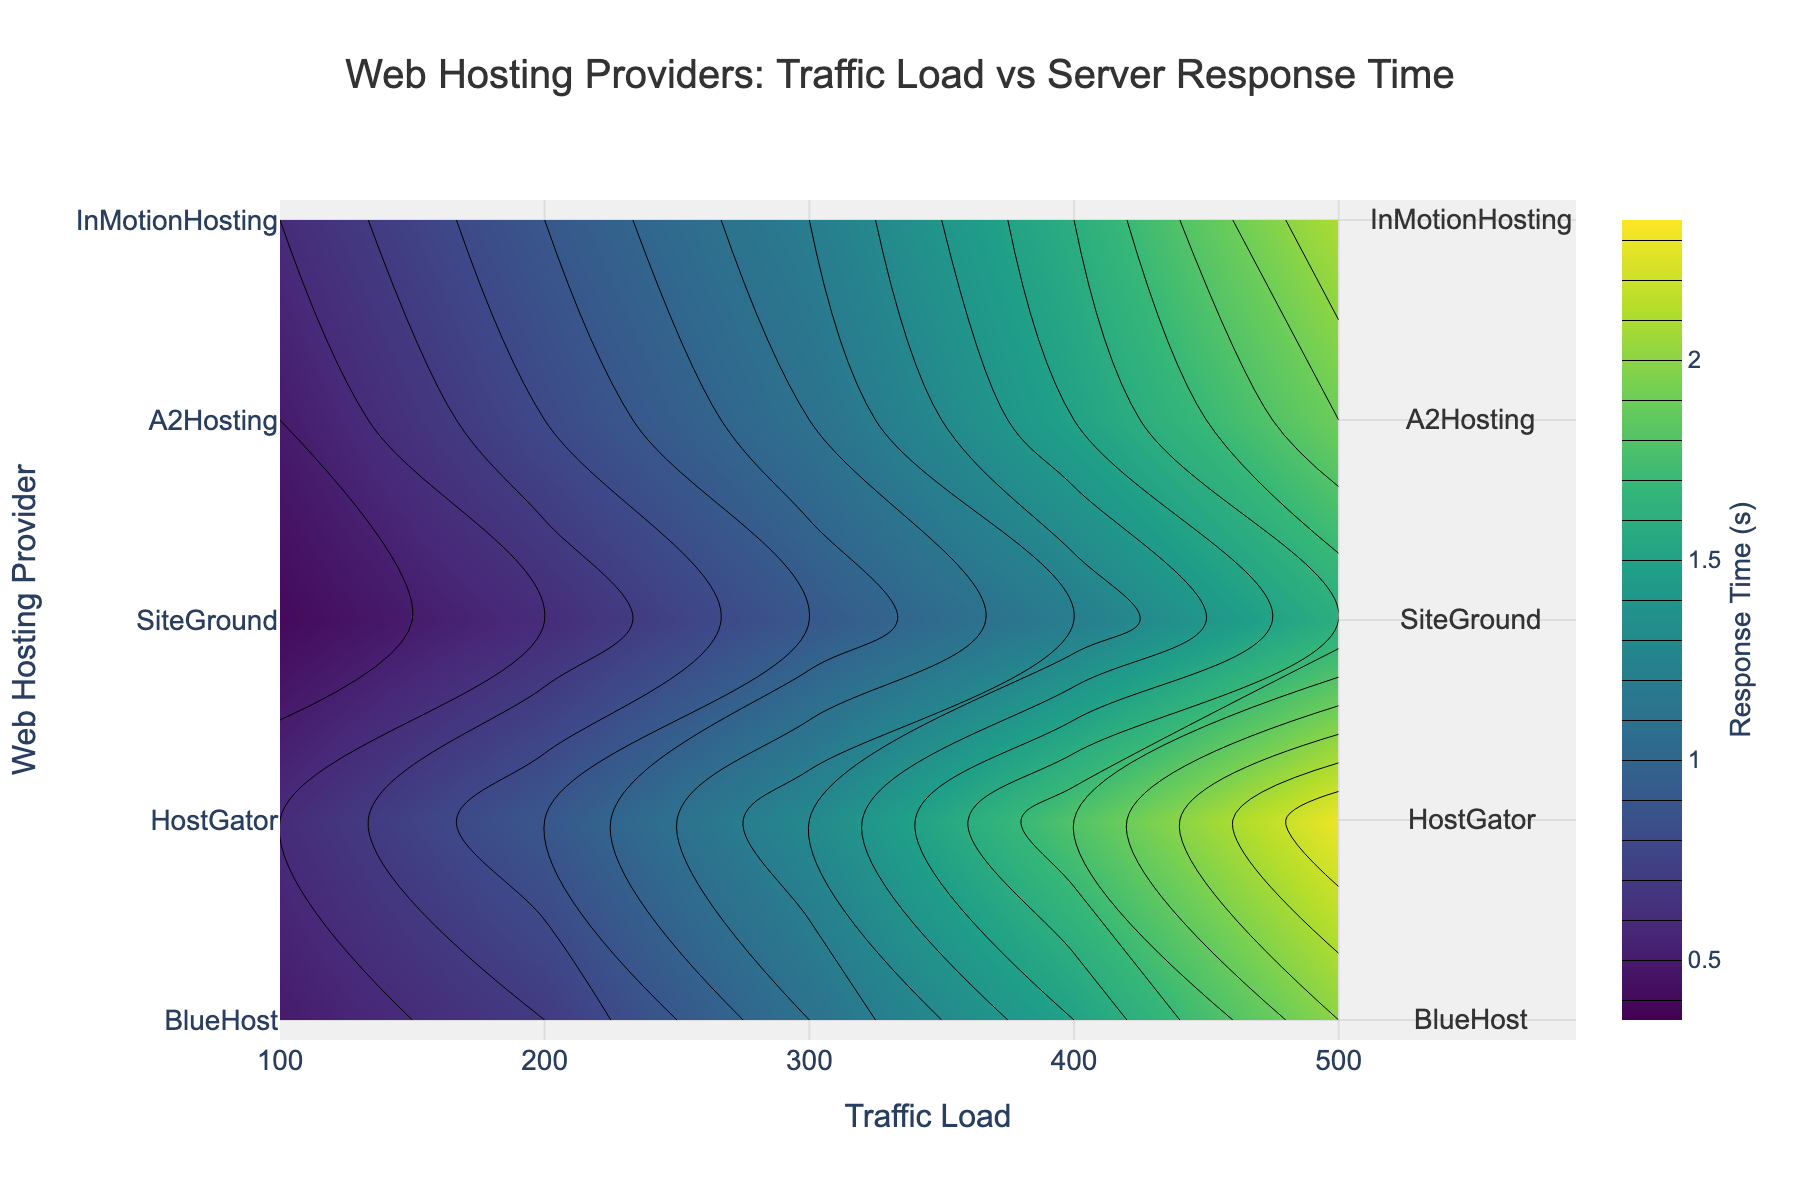What is the title of the plot? The title of the plot is usually placed at the top center of the figure, in this case, it reads 'Web Hosting Providers: Traffic Load vs Server Response Time'.
Answer: Web Hosting Providers: Traffic Load vs Server Response Time What information is displayed on the x-axis? The x-axis represents the 'Traffic Load', as indicated by the label at the bottom of the axis in the figure.
Answer: Traffic Load How many web hosting providers are displayed in the figure? The y-axis lists all web hosting providers, and by counting the distinct labels, there are 5 web hosting providers.
Answer: 5 Which web hosting provider has the lowest server response time at the highest traffic load? By checking the contour lines at the highest traffic load (500), the provider with the lowest response time is SiteGround.
Answer: SiteGround What color represents the highest server response time on the color scale? The color scale uses a gradient, where in the 'Viridis' colors, darker purple generally represents the highest values.
Answer: Dark purple Which hosting provider shows the fastest response time as traffic load increases from 100 to 500? Looking at the trend on the contour plot, SiteGround shows the fastest response time, maintaining the lowest values across increasing traffic load.
Answer: SiteGround Compare the server response time changes for BlueHost and HostGator as traffic load increases from 100 to 500. For both providers, the response time increases with traffic load. By observing the contour lines, HostGator's times are consistently higher than BlueHost's at each traffic level.
Answer: HostGator's response time increases more rapidly What is the approximate server response time for InMotionHosting at a traffic load of 300? Locate the intersection of '300' on the x-axis and 'InMotionHosting' on the y-axis, and estimate this position within the contour lines, which gives about 1.2 seconds.
Answer: 1.2 seconds What is the difference in server response time between A2Hosting and InMotionHosting at a traffic load of 400? Compare the values on the contour lines at 400 traffic load: A2Hosting's response time is 1.5 seconds, while InMotionHosting's is 1.6 seconds. The difference is 0.1 seconds.
Answer: 0.1 seconds Which web hosting provider has the most gradual incline in response time as traffic load increases? By observing the contour plot, SiteGround has the most gradual increase in response time as it consistently stays low across various traffic loads.
Answer: SiteGround 